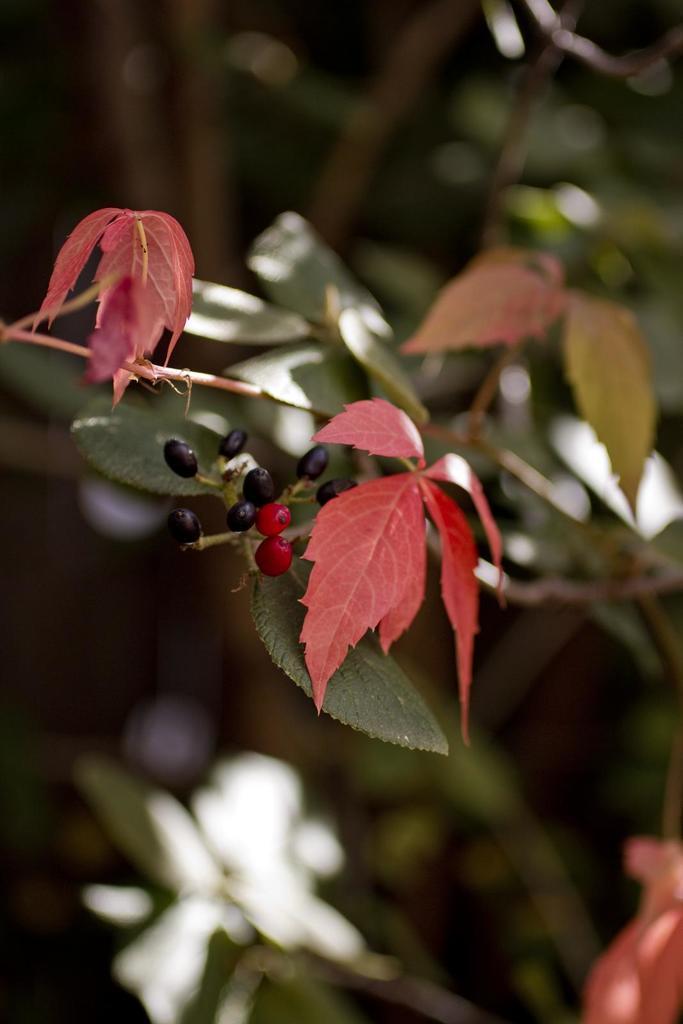Can you describe this image briefly? In this image we can see leaves, stems, and berries. There is a blur background. 